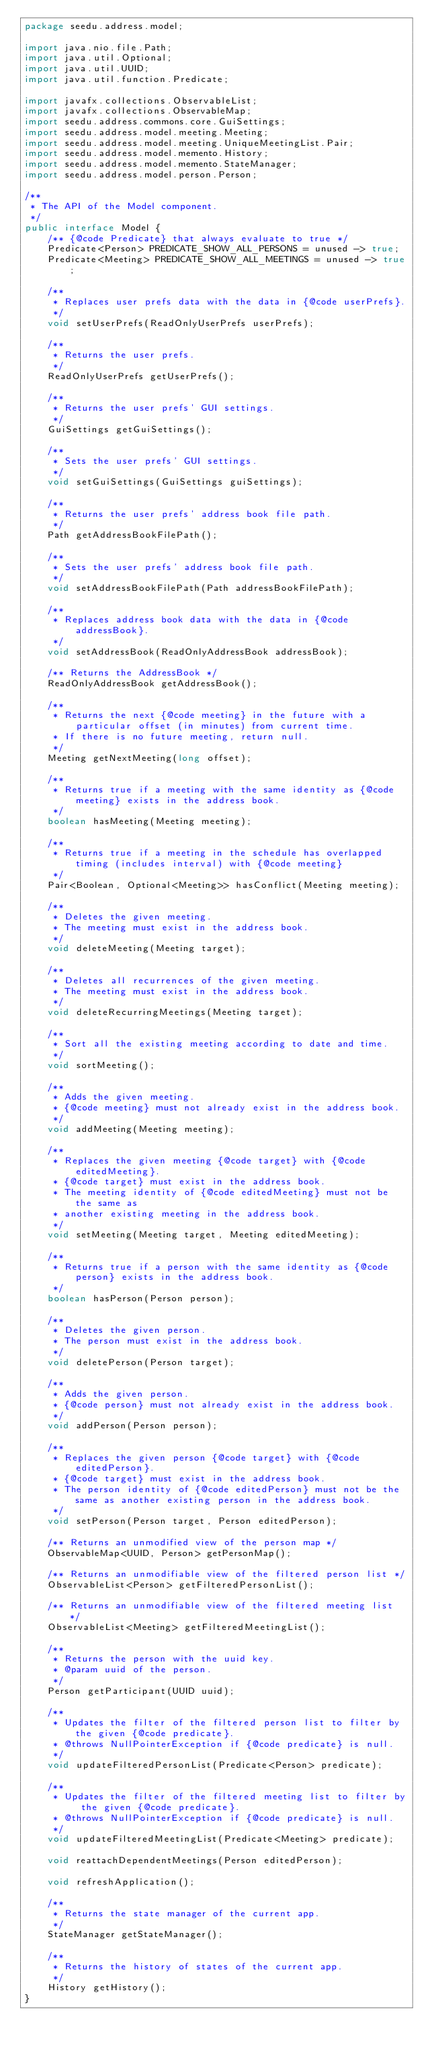Convert code to text. <code><loc_0><loc_0><loc_500><loc_500><_Java_>package seedu.address.model;

import java.nio.file.Path;
import java.util.Optional;
import java.util.UUID;
import java.util.function.Predicate;

import javafx.collections.ObservableList;
import javafx.collections.ObservableMap;
import seedu.address.commons.core.GuiSettings;
import seedu.address.model.meeting.Meeting;
import seedu.address.model.meeting.UniqueMeetingList.Pair;
import seedu.address.model.memento.History;
import seedu.address.model.memento.StateManager;
import seedu.address.model.person.Person;

/**
 * The API of the Model component.
 */
public interface Model {
    /** {@code Predicate} that always evaluate to true */
    Predicate<Person> PREDICATE_SHOW_ALL_PERSONS = unused -> true;
    Predicate<Meeting> PREDICATE_SHOW_ALL_MEETINGS = unused -> true;

    /**
     * Replaces user prefs data with the data in {@code userPrefs}.
     */
    void setUserPrefs(ReadOnlyUserPrefs userPrefs);

    /**
     * Returns the user prefs.
     */
    ReadOnlyUserPrefs getUserPrefs();

    /**
     * Returns the user prefs' GUI settings.
     */
    GuiSettings getGuiSettings();

    /**
     * Sets the user prefs' GUI settings.
     */
    void setGuiSettings(GuiSettings guiSettings);

    /**
     * Returns the user prefs' address book file path.
     */
    Path getAddressBookFilePath();

    /**
     * Sets the user prefs' address book file path.
     */
    void setAddressBookFilePath(Path addressBookFilePath);

    /**
     * Replaces address book data with the data in {@code addressBook}.
     */
    void setAddressBook(ReadOnlyAddressBook addressBook);

    /** Returns the AddressBook */
    ReadOnlyAddressBook getAddressBook();

    /**
     * Returns the next {@code meeting} in the future with a particular offset (in minutes) from current time.
     * If there is no future meeting, return null.
     */
    Meeting getNextMeeting(long offset);

    /**
     * Returns true if a meeting with the same identity as {@code meeting} exists in the address book.
     */
    boolean hasMeeting(Meeting meeting);

    /**
     * Returns true if a meeting in the schedule has overlapped timing (includes interval) with {@code meeting}
     */
    Pair<Boolean, Optional<Meeting>> hasConflict(Meeting meeting);

    /**
     * Deletes the given meeting.
     * The meeting must exist in the address book.
     */
    void deleteMeeting(Meeting target);

    /**
     * Deletes all recurrences of the given meeting.
     * The meeting must exist in the address book.
     */
    void deleteRecurringMeetings(Meeting target);

    /**
     * Sort all the existing meeting according to date and time.
     */
    void sortMeeting();

    /**
     * Adds the given meeting.
     * {@code meeting} must not already exist in the address book.
     */
    void addMeeting(Meeting meeting);

    /**
     * Replaces the given meeting {@code target} with {@code editedMeeting}.
     * {@code target} must exist in the address book.
     * The meeting identity of {@code editedMeeting} must not be the same as
     * another existing meeting in the address book.
     */
    void setMeeting(Meeting target, Meeting editedMeeting);

    /**
     * Returns true if a person with the same identity as {@code person} exists in the address book.
     */
    boolean hasPerson(Person person);

    /**
     * Deletes the given person.
     * The person must exist in the address book.
     */
    void deletePerson(Person target);

    /**
     * Adds the given person.
     * {@code person} must not already exist in the address book.
     */
    void addPerson(Person person);

    /**
     * Replaces the given person {@code target} with {@code editedPerson}.
     * {@code target} must exist in the address book.
     * The person identity of {@code editedPerson} must not be the same as another existing person in the address book.
     */
    void setPerson(Person target, Person editedPerson);

    /** Returns an unmodified view of the person map */
    ObservableMap<UUID, Person> getPersonMap();

    /** Returns an unmodifiable view of the filtered person list */
    ObservableList<Person> getFilteredPersonList();

    /** Returns an unmodifiable view of the filtered meeting list */
    ObservableList<Meeting> getFilteredMeetingList();

    /**
     * Returns the person with the uuid key.
     * @param uuid of the person.
     */
    Person getParticipant(UUID uuid);

    /**
     * Updates the filter of the filtered person list to filter by the given {@code predicate}.
     * @throws NullPointerException if {@code predicate} is null.
     */
    void updateFilteredPersonList(Predicate<Person> predicate);

    /**
     * Updates the filter of the filtered meeting list to filter by the given {@code predicate}.
     * @throws NullPointerException if {@code predicate} is null.
     */
    void updateFilteredMeetingList(Predicate<Meeting> predicate);

    void reattachDependentMeetings(Person editedPerson);

    void refreshApplication();

    /**
     * Returns the state manager of the current app.
     */
    StateManager getStateManager();

    /**
     * Returns the history of states of the current app.
     */
    History getHistory();
}
</code> 